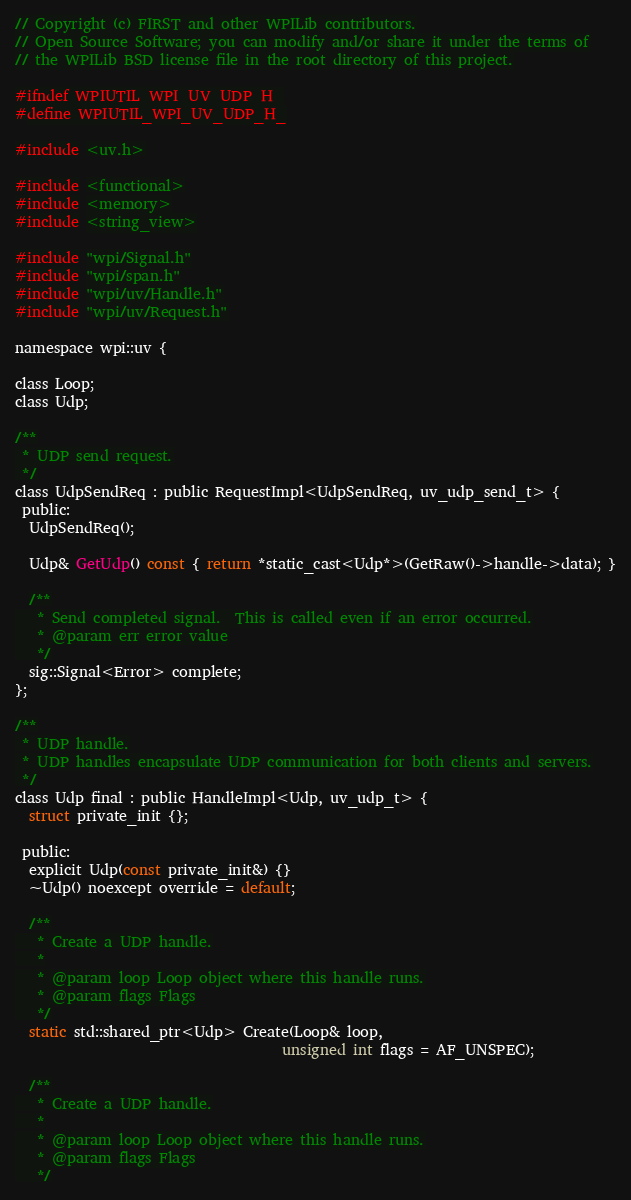<code> <loc_0><loc_0><loc_500><loc_500><_C_>// Copyright (c) FIRST and other WPILib contributors.
// Open Source Software; you can modify and/or share it under the terms of
// the WPILib BSD license file in the root directory of this project.

#ifndef WPIUTIL_WPI_UV_UDP_H_
#define WPIUTIL_WPI_UV_UDP_H_

#include <uv.h>

#include <functional>
#include <memory>
#include <string_view>

#include "wpi/Signal.h"
#include "wpi/span.h"
#include "wpi/uv/Handle.h"
#include "wpi/uv/Request.h"

namespace wpi::uv {

class Loop;
class Udp;

/**
 * UDP send request.
 */
class UdpSendReq : public RequestImpl<UdpSendReq, uv_udp_send_t> {
 public:
  UdpSendReq();

  Udp& GetUdp() const { return *static_cast<Udp*>(GetRaw()->handle->data); }

  /**
   * Send completed signal.  This is called even if an error occurred.
   * @param err error value
   */
  sig::Signal<Error> complete;
};

/**
 * UDP handle.
 * UDP handles encapsulate UDP communication for both clients and servers.
 */
class Udp final : public HandleImpl<Udp, uv_udp_t> {
  struct private_init {};

 public:
  explicit Udp(const private_init&) {}
  ~Udp() noexcept override = default;

  /**
   * Create a UDP handle.
   *
   * @param loop Loop object where this handle runs.
   * @param flags Flags
   */
  static std::shared_ptr<Udp> Create(Loop& loop,
                                     unsigned int flags = AF_UNSPEC);

  /**
   * Create a UDP handle.
   *
   * @param loop Loop object where this handle runs.
   * @param flags Flags
   */</code> 